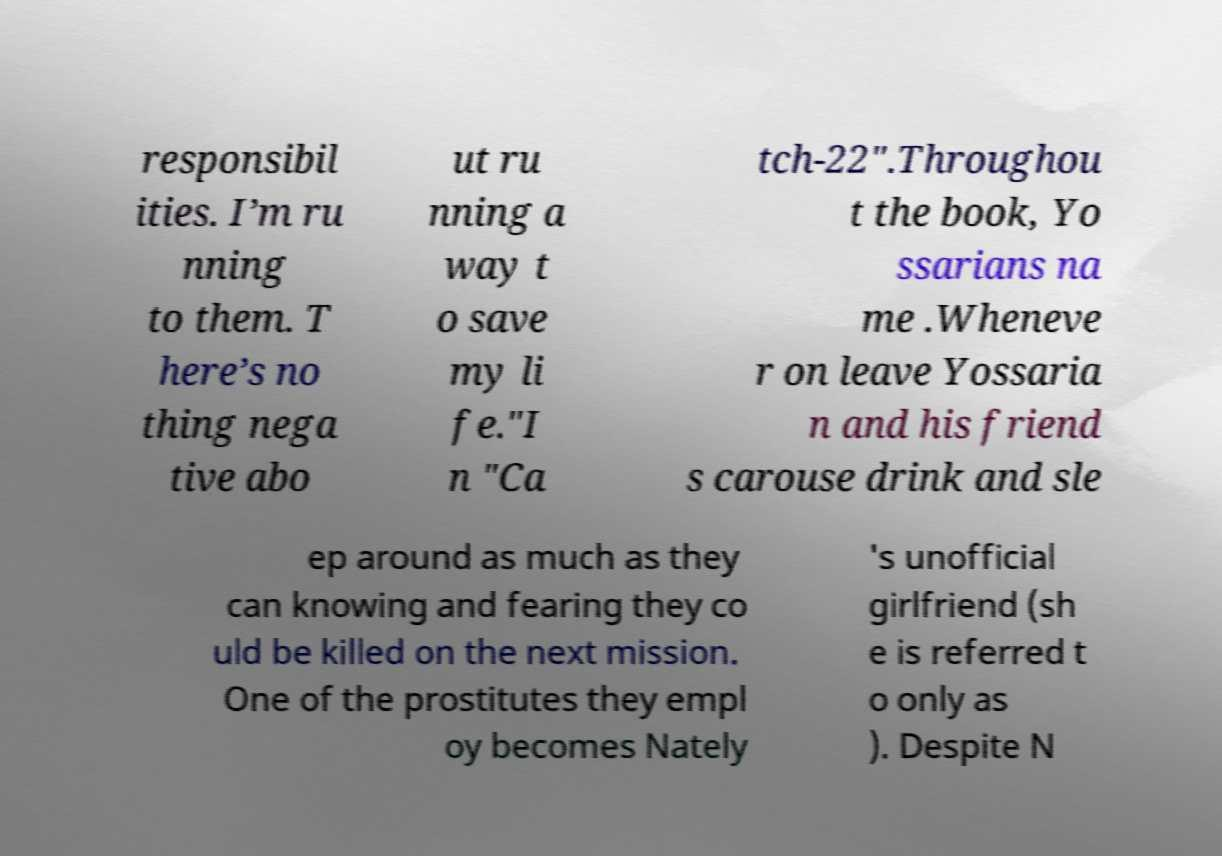There's text embedded in this image that I need extracted. Can you transcribe it verbatim? responsibil ities. I’m ru nning to them. T here’s no thing nega tive abo ut ru nning a way t o save my li fe."I n "Ca tch-22".Throughou t the book, Yo ssarians na me .Wheneve r on leave Yossaria n and his friend s carouse drink and sle ep around as much as they can knowing and fearing they co uld be killed on the next mission. One of the prostitutes they empl oy becomes Nately 's unofficial girlfriend (sh e is referred t o only as ). Despite N 